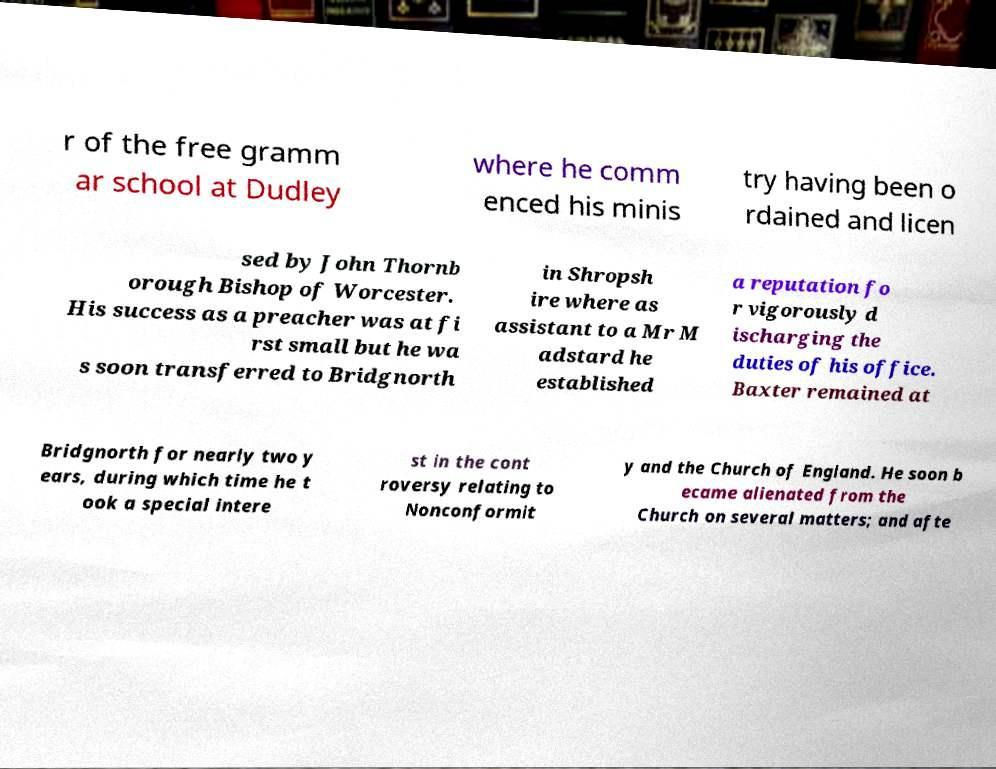Please read and relay the text visible in this image. What does it say? r of the free gramm ar school at Dudley where he comm enced his minis try having been o rdained and licen sed by John Thornb orough Bishop of Worcester. His success as a preacher was at fi rst small but he wa s soon transferred to Bridgnorth in Shropsh ire where as assistant to a Mr M adstard he established a reputation fo r vigorously d ischarging the duties of his office. Baxter remained at Bridgnorth for nearly two y ears, during which time he t ook a special intere st in the cont roversy relating to Nonconformit y and the Church of England. He soon b ecame alienated from the Church on several matters; and afte 